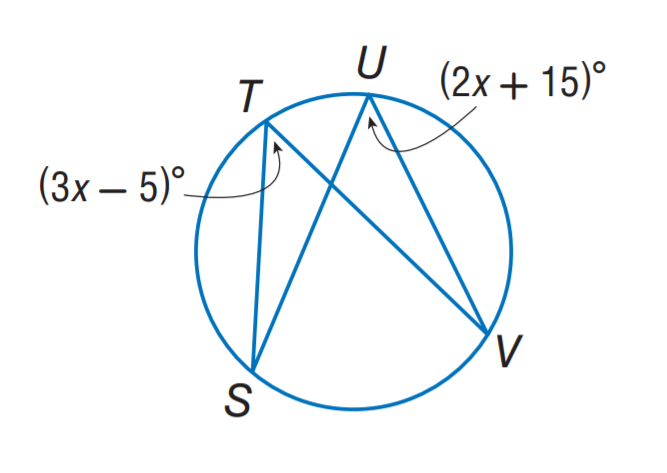Question: Find m \angle T.
Choices:
A. 15
B. 35
C. 55
D. 60
Answer with the letter. Answer: C Question: If m \angle S = 3 x and m \angle V = x + 16, find m \angle S.
Choices:
A. 16
B. 24
C. 32
D. 48
Answer with the letter. Answer: B 